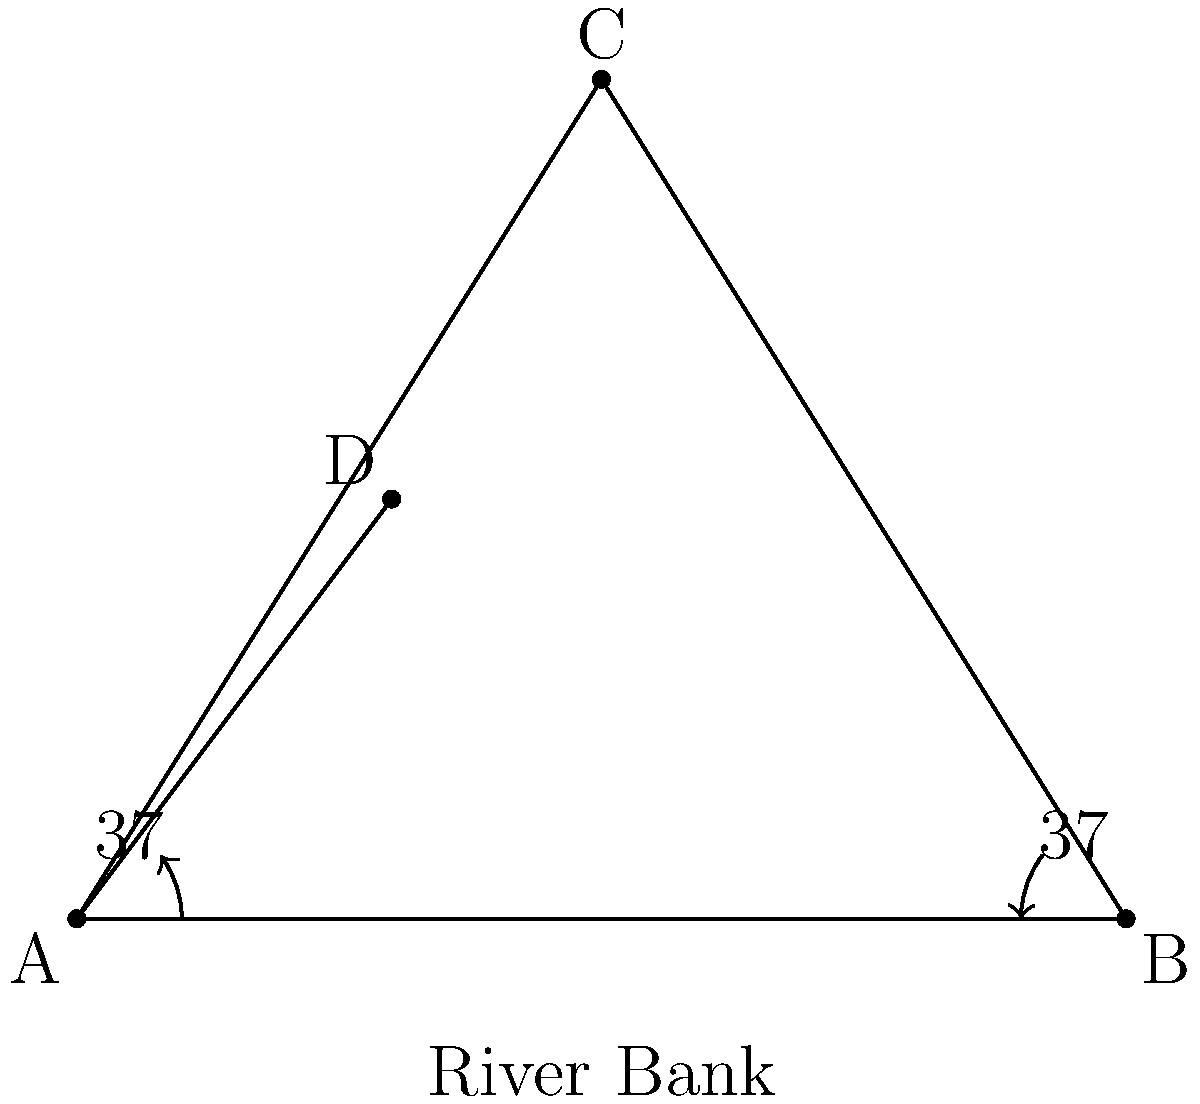During a rowing practice, you and Harry Brightmore are in separate boats on a river. Your boat is at point A, and Harry's boat is at point D. Two landmarks, B and C, are visible on the riverbank. The distance between landmarks B and C is 120 meters. From your position (A), you measure the angle between B and C to be 74°. From landmark B, the angle between your boat (A) and Harry's boat (D) is measured as 37°. Using this information, calculate the distance between your boat and Harry's boat. Let's approach this step-by-step:

1) First, we need to find the distance AB using the law of sines in triangle ABC:

   $$\frac{AB}{\sin 74°} = \frac{BC}{\sin 53°}$$

   (Note: 53° is used because the sum of angles in a triangle is 180°, so 180° - 74° - 53° = 53°)

2) Rearranging the equation:

   $$AB = \frac{BC \cdot \sin 74°}{\sin 53°}$$

3) Plugging in the known value of BC = 120 meters:

   $$AB = \frac{120 \cdot \sin 74°}{\sin 53°} \approx 141.42 \text{ meters}$$

4) Now, in triangle ABD, we know AB and the angle at B (37°). We can use the law of sines again to find AD:

   $$\frac{AD}{\sin 37°} = \frac{AB}{\sin 106°}$$

   (Note: 106° is used because 180° - 37° - 37° = 106°)

5) Rearranging:

   $$AD = \frac{AB \cdot \sin 37°}{\sin 106°}$$

6) Plugging in the value of AB we found:

   $$AD = \frac{141.42 \cdot \sin 37°}{\sin 106°} \approx 85.60 \text{ meters}$$

Therefore, the distance between your boat and Harry's boat is approximately 85.60 meters.
Answer: 85.60 meters 